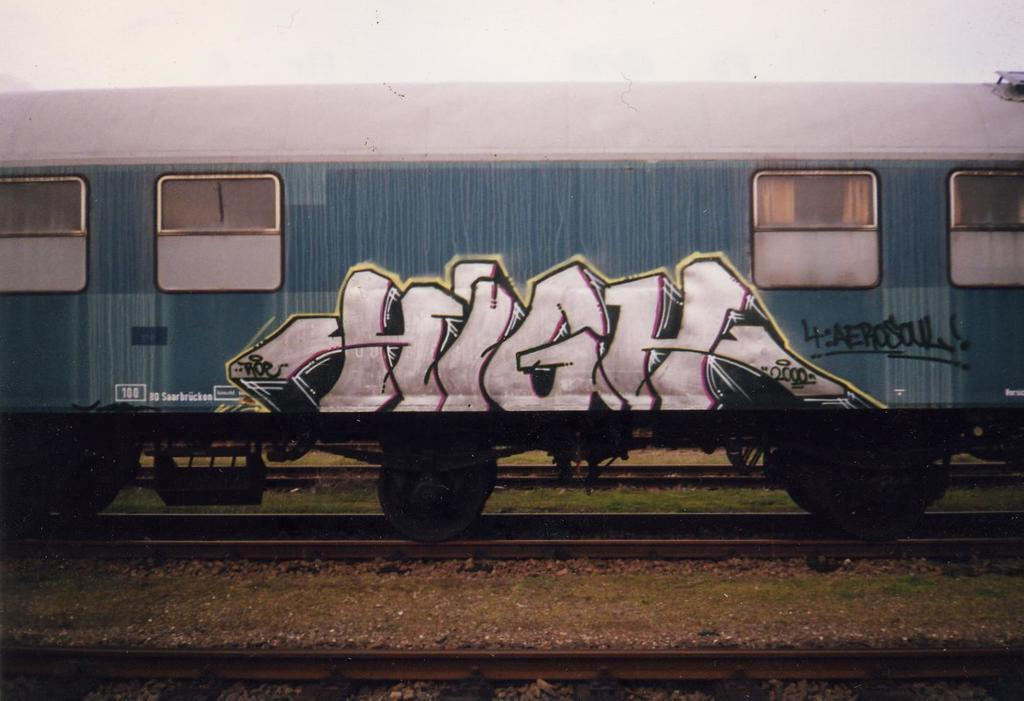Provide a one-sentence caption for the provided image. the word high in graffiti on the side of a train. 